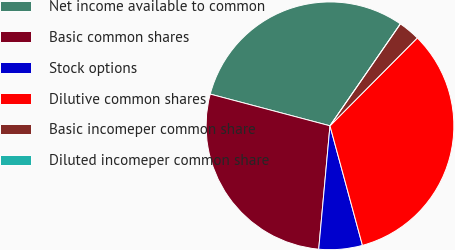Convert chart to OTSL. <chart><loc_0><loc_0><loc_500><loc_500><pie_chart><fcel>Net income available to common<fcel>Basic common shares<fcel>Stock options<fcel>Dilutive common shares<fcel>Basic incomeper common share<fcel>Diluted incomeper common share<nl><fcel>30.5%<fcel>27.67%<fcel>5.67%<fcel>33.33%<fcel>2.83%<fcel>0.0%<nl></chart> 